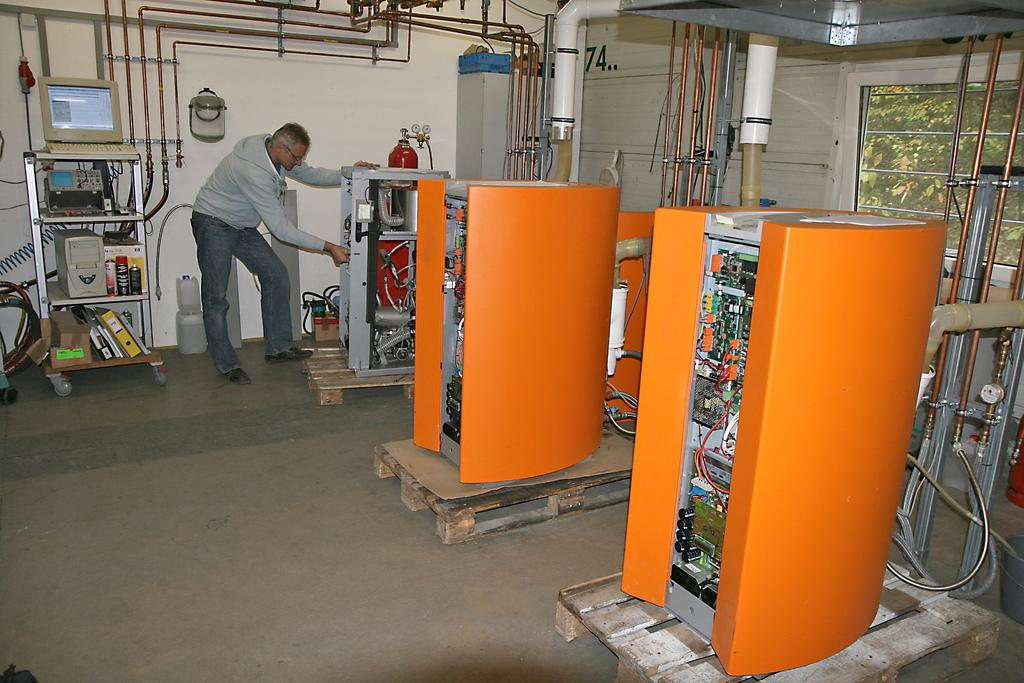<image>
Describe the image concisely. A man works on a unit in a building with orange electrical units and an old style computer on a shelf. 